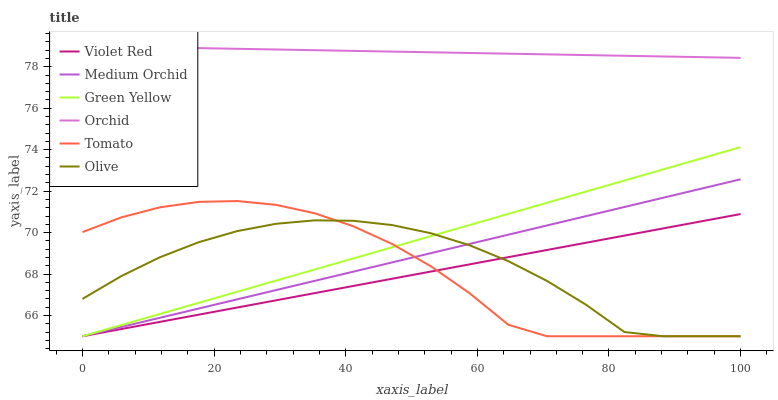Does Violet Red have the minimum area under the curve?
Answer yes or no. Yes. Does Orchid have the maximum area under the curve?
Answer yes or no. Yes. Does Medium Orchid have the minimum area under the curve?
Answer yes or no. No. Does Medium Orchid have the maximum area under the curve?
Answer yes or no. No. Is Orchid the smoothest?
Answer yes or no. Yes. Is Tomato the roughest?
Answer yes or no. Yes. Is Violet Red the smoothest?
Answer yes or no. No. Is Violet Red the roughest?
Answer yes or no. No. Does Tomato have the lowest value?
Answer yes or no. Yes. Does Orchid have the lowest value?
Answer yes or no. No. Does Orchid have the highest value?
Answer yes or no. Yes. Does Violet Red have the highest value?
Answer yes or no. No. Is Green Yellow less than Orchid?
Answer yes or no. Yes. Is Orchid greater than Tomato?
Answer yes or no. Yes. Does Olive intersect Medium Orchid?
Answer yes or no. Yes. Is Olive less than Medium Orchid?
Answer yes or no. No. Is Olive greater than Medium Orchid?
Answer yes or no. No. Does Green Yellow intersect Orchid?
Answer yes or no. No. 